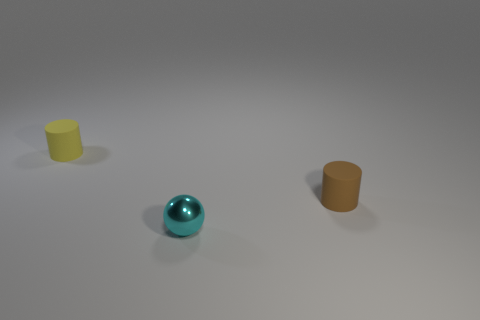There is a object that is both in front of the yellow matte cylinder and on the left side of the tiny brown cylinder; what shape is it?
Ensure brevity in your answer.  Sphere. Are there the same number of small brown matte cylinders that are behind the yellow rubber cylinder and tiny objects right of the cyan shiny object?
Give a very brief answer. No. How many things are either tiny cubes or tiny yellow things?
Ensure brevity in your answer.  1. There is a metal ball that is the same size as the yellow cylinder; what color is it?
Ensure brevity in your answer.  Cyan. How many things are either cylinders that are left of the brown cylinder or tiny cyan things in front of the tiny yellow rubber thing?
Offer a terse response. 2. Are there the same number of yellow matte things that are in front of the yellow matte cylinder and gray rubber objects?
Your response must be concise. Yes. How many other things are there of the same size as the cyan sphere?
Your response must be concise. 2. There is a tiny rubber object that is behind the rubber object that is to the right of the yellow rubber thing; is there a cyan thing to the right of it?
Offer a very short reply. Yes. Are there any other things that are the same color as the metal object?
Give a very brief answer. No. There is a rubber cylinder left of the cylinder that is to the right of the small sphere; what color is it?
Your response must be concise. Yellow. 